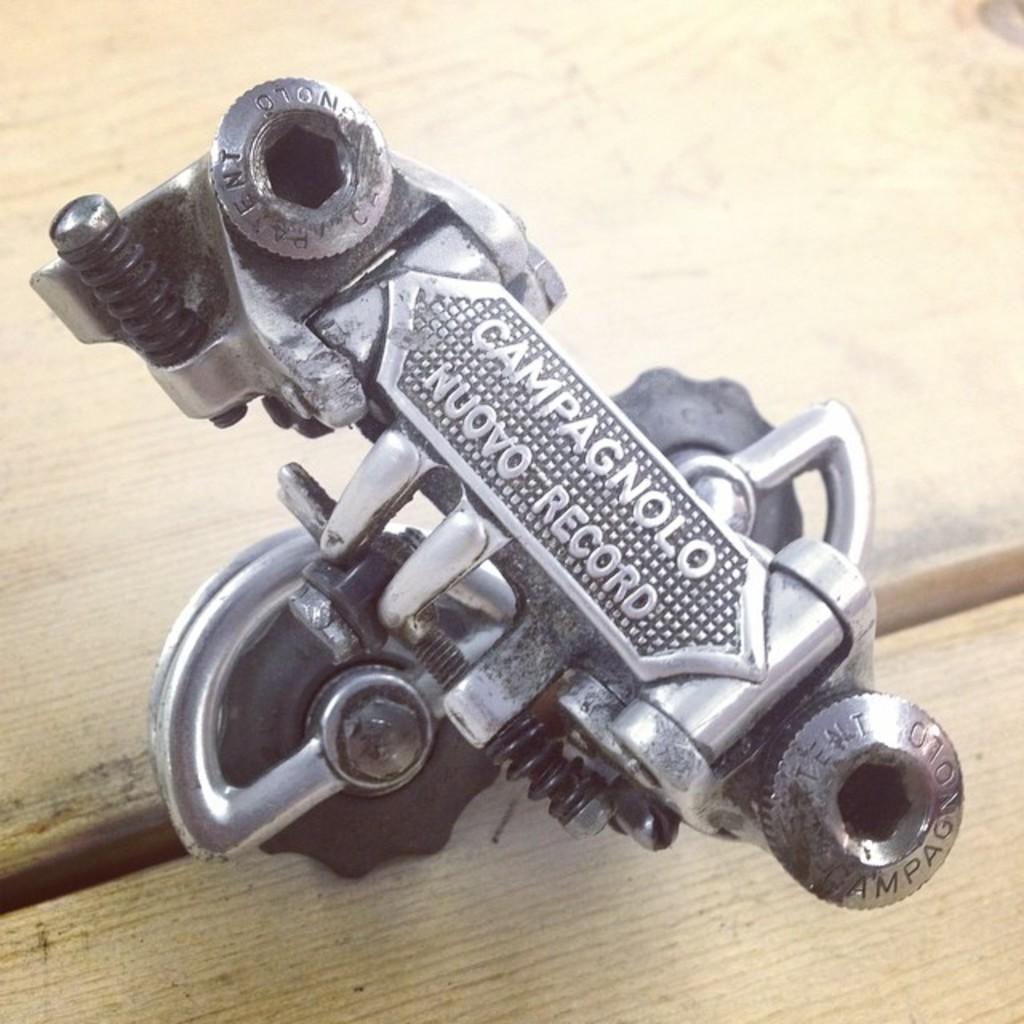Describe this image in one or two sentences. In this image there is a metal object with some text on it on the table. 